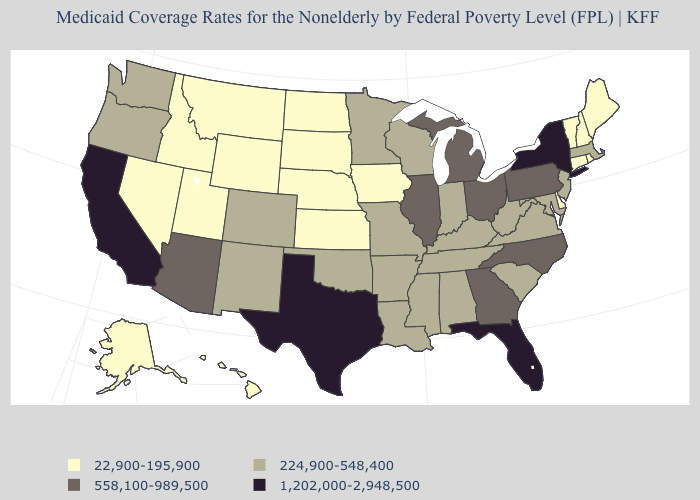Does Delaware have the lowest value in the South?
Give a very brief answer. Yes. What is the value of Hawaii?
Quick response, please. 22,900-195,900. What is the highest value in the USA?
Write a very short answer. 1,202,000-2,948,500. Name the states that have a value in the range 558,100-989,500?
Quick response, please. Arizona, Georgia, Illinois, Michigan, North Carolina, Ohio, Pennsylvania. Name the states that have a value in the range 558,100-989,500?
Write a very short answer. Arizona, Georgia, Illinois, Michigan, North Carolina, Ohio, Pennsylvania. Name the states that have a value in the range 22,900-195,900?
Concise answer only. Alaska, Connecticut, Delaware, Hawaii, Idaho, Iowa, Kansas, Maine, Montana, Nebraska, Nevada, New Hampshire, North Dakota, Rhode Island, South Dakota, Utah, Vermont, Wyoming. Which states hav the highest value in the South?
Give a very brief answer. Florida, Texas. Among the states that border Arkansas , which have the lowest value?
Quick response, please. Louisiana, Mississippi, Missouri, Oklahoma, Tennessee. Does Vermont have the highest value in the USA?
Quick response, please. No. Name the states that have a value in the range 22,900-195,900?
Concise answer only. Alaska, Connecticut, Delaware, Hawaii, Idaho, Iowa, Kansas, Maine, Montana, Nebraska, Nevada, New Hampshire, North Dakota, Rhode Island, South Dakota, Utah, Vermont, Wyoming. Does the map have missing data?
Concise answer only. No. What is the value of Alaska?
Be succinct. 22,900-195,900. Which states hav the highest value in the MidWest?
Give a very brief answer. Illinois, Michigan, Ohio. Among the states that border Virginia , does North Carolina have the highest value?
Keep it brief. Yes. Does Montana have a lower value than New Mexico?
Answer briefly. Yes. 